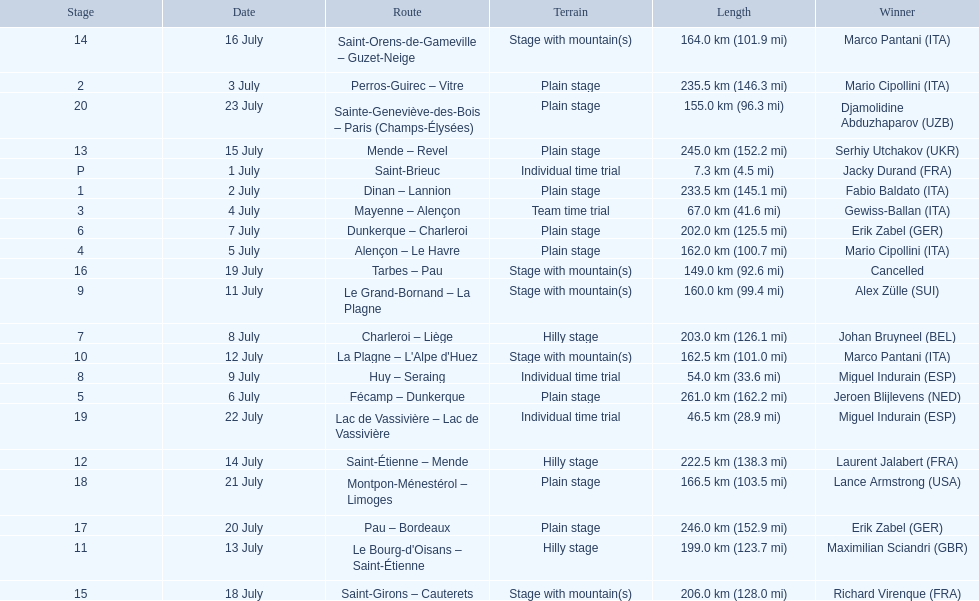What were the dates of the 1995 tour de france? 1 July, 2 July, 3 July, 4 July, 5 July, 6 July, 7 July, 8 July, 9 July, 11 July, 12 July, 13 July, 14 July, 15 July, 16 July, 18 July, 19 July, 20 July, 21 July, 22 July, 23 July. What was the length for july 8th? 203.0 km (126.1 mi). 